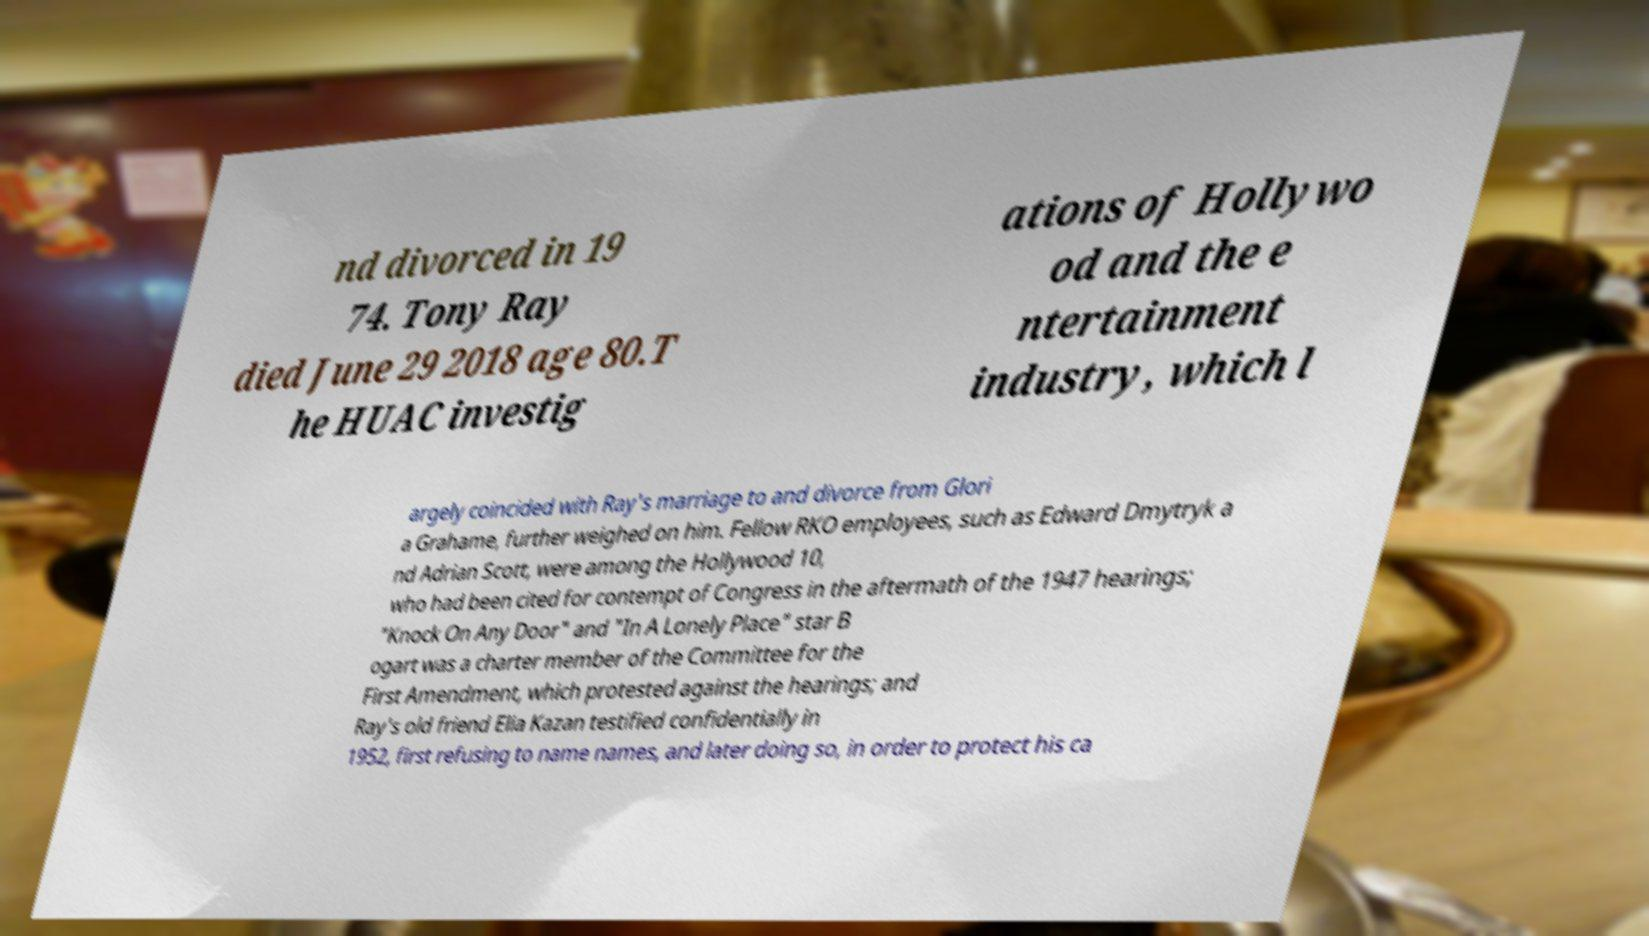Please identify and transcribe the text found in this image. nd divorced in 19 74. Tony Ray died June 29 2018 age 80.T he HUAC investig ations of Hollywo od and the e ntertainment industry, which l argely coincided with Ray's marriage to and divorce from Glori a Grahame, further weighed on him. Fellow RKO employees, such as Edward Dmytryk a nd Adrian Scott, were among the Hollywood 10, who had been cited for contempt of Congress in the aftermath of the 1947 hearings; "Knock On Any Door" and "In A Lonely Place" star B ogart was a charter member of the Committee for the First Amendment, which protested against the hearings; and Ray's old friend Elia Kazan testified confidentially in 1952, first refusing to name names, and later doing so, in order to protect his ca 